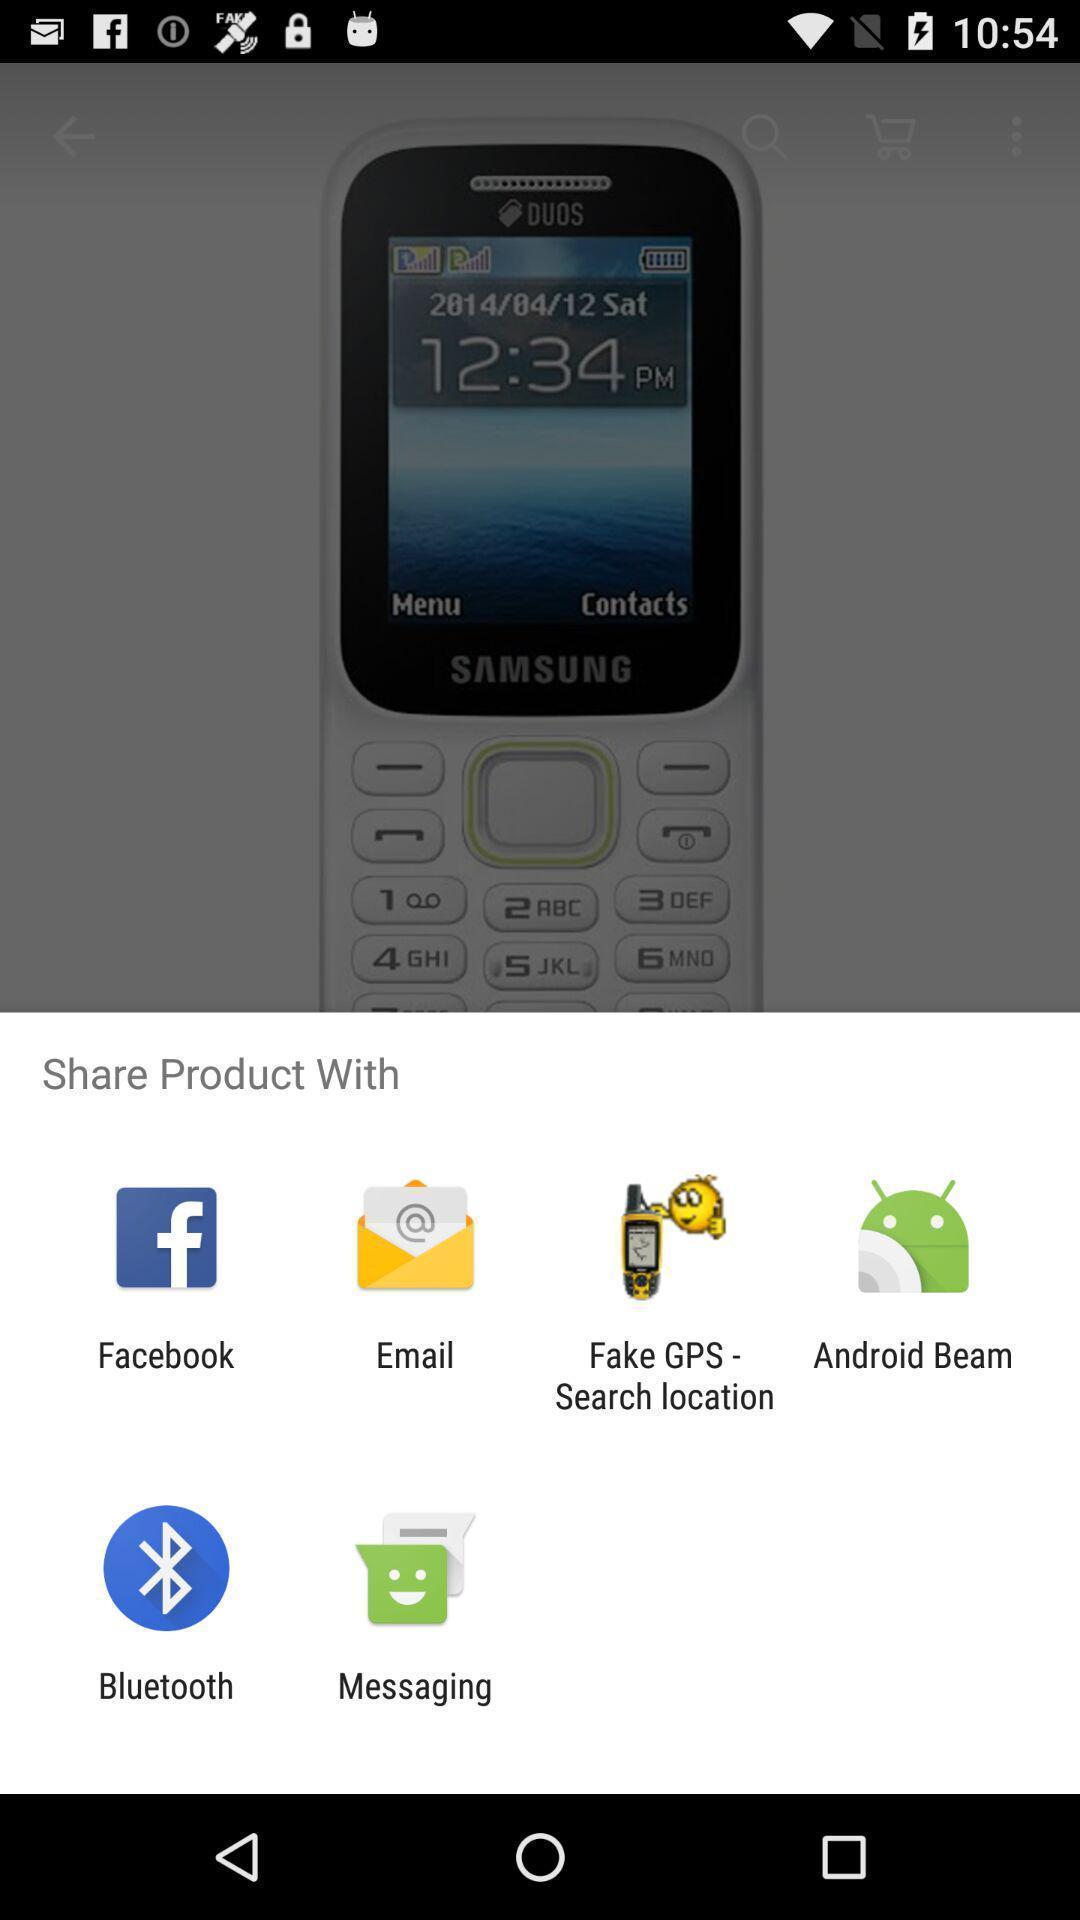Give me a narrative description of this picture. Pop up page for sharing product through different apps. 